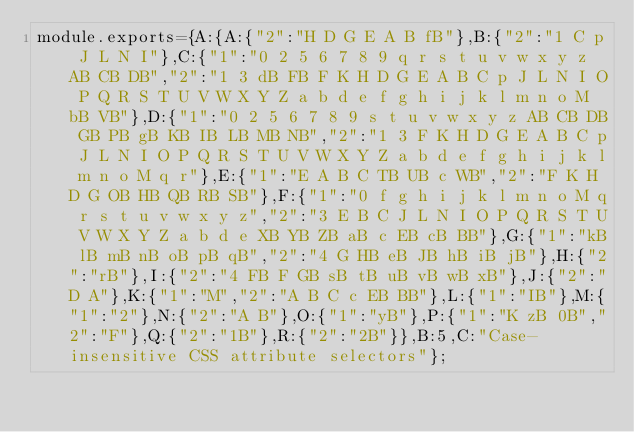Convert code to text. <code><loc_0><loc_0><loc_500><loc_500><_JavaScript_>module.exports={A:{A:{"2":"H D G E A B fB"},B:{"2":"1 C p J L N I"},C:{"1":"0 2 5 6 7 8 9 q r s t u v w x y z AB CB DB","2":"1 3 dB FB F K H D G E A B C p J L N I O P Q R S T U V W X Y Z a b d e f g h i j k l m n o M bB VB"},D:{"1":"0 2 5 6 7 8 9 s t u v w x y z AB CB DB GB PB gB KB IB LB MB NB","2":"1 3 F K H D G E A B C p J L N I O P Q R S T U V W X Y Z a b d e f g h i j k l m n o M q r"},E:{"1":"E A B C TB UB c WB","2":"F K H D G OB HB QB RB SB"},F:{"1":"0 f g h i j k l m n o M q r s t u v w x y z","2":"3 E B C J L N I O P Q R S T U V W X Y Z a b d e XB YB ZB aB c EB cB BB"},G:{"1":"kB lB mB nB oB pB qB","2":"4 G HB eB JB hB iB jB"},H:{"2":"rB"},I:{"2":"4 FB F GB sB tB uB vB wB xB"},J:{"2":"D A"},K:{"1":"M","2":"A B C c EB BB"},L:{"1":"IB"},M:{"1":"2"},N:{"2":"A B"},O:{"1":"yB"},P:{"1":"K zB 0B","2":"F"},Q:{"2":"1B"},R:{"2":"2B"}},B:5,C:"Case-insensitive CSS attribute selectors"};
</code> 